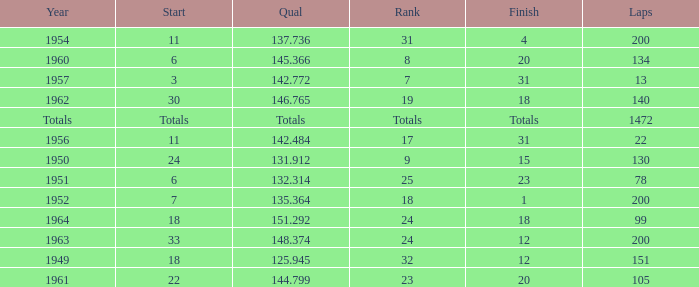Name the rank with laps of 200 and qual of 148.374 24.0. 